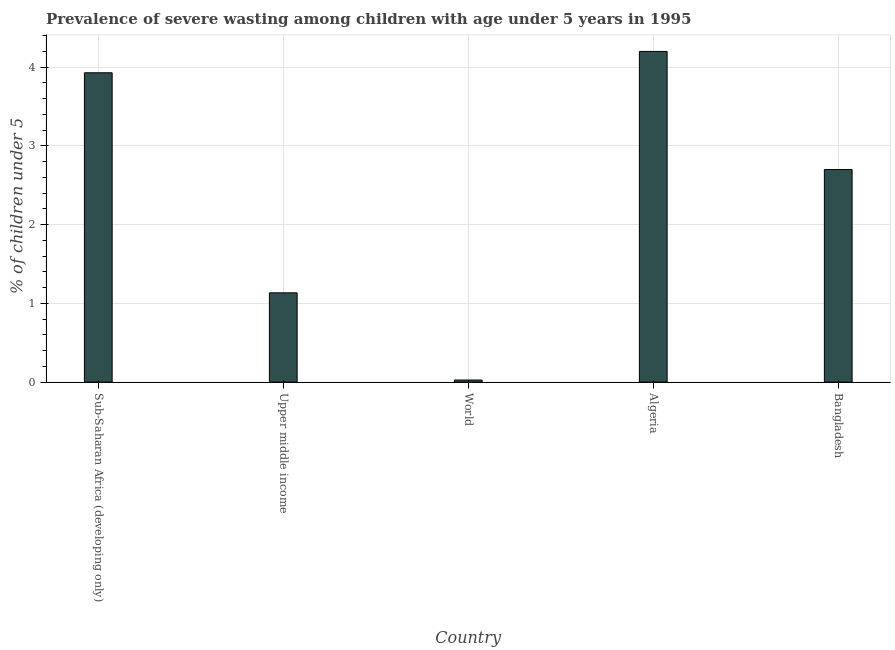Does the graph contain grids?
Provide a succinct answer. Yes. What is the title of the graph?
Make the answer very short. Prevalence of severe wasting among children with age under 5 years in 1995. What is the label or title of the Y-axis?
Provide a short and direct response.  % of children under 5. What is the prevalence of severe wasting in Sub-Saharan Africa (developing only)?
Provide a succinct answer. 3.93. Across all countries, what is the maximum prevalence of severe wasting?
Your answer should be compact. 4.2. Across all countries, what is the minimum prevalence of severe wasting?
Ensure brevity in your answer.  0.03. In which country was the prevalence of severe wasting maximum?
Offer a terse response. Algeria. What is the sum of the prevalence of severe wasting?
Keep it short and to the point. 11.99. What is the difference between the prevalence of severe wasting in Bangladesh and Upper middle income?
Make the answer very short. 1.57. What is the average prevalence of severe wasting per country?
Ensure brevity in your answer.  2.4. What is the median prevalence of severe wasting?
Give a very brief answer. 2.7. In how many countries, is the prevalence of severe wasting greater than 3.6 %?
Your answer should be very brief. 2. What is the ratio of the prevalence of severe wasting in Sub-Saharan Africa (developing only) to that in World?
Ensure brevity in your answer.  145.15. Is the prevalence of severe wasting in Algeria less than that in World?
Your answer should be very brief. No. What is the difference between the highest and the second highest prevalence of severe wasting?
Keep it short and to the point. 0.27. What is the difference between the highest and the lowest prevalence of severe wasting?
Offer a terse response. 4.17. In how many countries, is the prevalence of severe wasting greater than the average prevalence of severe wasting taken over all countries?
Provide a short and direct response. 3. How many countries are there in the graph?
Keep it short and to the point. 5. What is the difference between two consecutive major ticks on the Y-axis?
Ensure brevity in your answer.  1. Are the values on the major ticks of Y-axis written in scientific E-notation?
Offer a very short reply. No. What is the  % of children under 5 in Sub-Saharan Africa (developing only)?
Your answer should be very brief. 3.93. What is the  % of children under 5 of Upper middle income?
Your response must be concise. 1.13. What is the  % of children under 5 of World?
Provide a short and direct response. 0.03. What is the  % of children under 5 in Algeria?
Your answer should be compact. 4.2. What is the  % of children under 5 of Bangladesh?
Ensure brevity in your answer.  2.7. What is the difference between the  % of children under 5 in Sub-Saharan Africa (developing only) and Upper middle income?
Ensure brevity in your answer.  2.79. What is the difference between the  % of children under 5 in Sub-Saharan Africa (developing only) and World?
Your answer should be very brief. 3.9. What is the difference between the  % of children under 5 in Sub-Saharan Africa (developing only) and Algeria?
Provide a short and direct response. -0.27. What is the difference between the  % of children under 5 in Sub-Saharan Africa (developing only) and Bangladesh?
Ensure brevity in your answer.  1.23. What is the difference between the  % of children under 5 in Upper middle income and World?
Offer a very short reply. 1.11. What is the difference between the  % of children under 5 in Upper middle income and Algeria?
Offer a very short reply. -3.07. What is the difference between the  % of children under 5 in Upper middle income and Bangladesh?
Keep it short and to the point. -1.57. What is the difference between the  % of children under 5 in World and Algeria?
Keep it short and to the point. -4.17. What is the difference between the  % of children under 5 in World and Bangladesh?
Offer a very short reply. -2.67. What is the ratio of the  % of children under 5 in Sub-Saharan Africa (developing only) to that in Upper middle income?
Your answer should be very brief. 3.46. What is the ratio of the  % of children under 5 in Sub-Saharan Africa (developing only) to that in World?
Give a very brief answer. 145.15. What is the ratio of the  % of children under 5 in Sub-Saharan Africa (developing only) to that in Algeria?
Provide a succinct answer. 0.94. What is the ratio of the  % of children under 5 in Sub-Saharan Africa (developing only) to that in Bangladesh?
Your response must be concise. 1.46. What is the ratio of the  % of children under 5 in Upper middle income to that in World?
Provide a succinct answer. 41.91. What is the ratio of the  % of children under 5 in Upper middle income to that in Algeria?
Provide a short and direct response. 0.27. What is the ratio of the  % of children under 5 in Upper middle income to that in Bangladesh?
Your answer should be compact. 0.42. What is the ratio of the  % of children under 5 in World to that in Algeria?
Your answer should be compact. 0.01. What is the ratio of the  % of children under 5 in World to that in Bangladesh?
Your answer should be very brief. 0.01. What is the ratio of the  % of children under 5 in Algeria to that in Bangladesh?
Offer a very short reply. 1.56. 